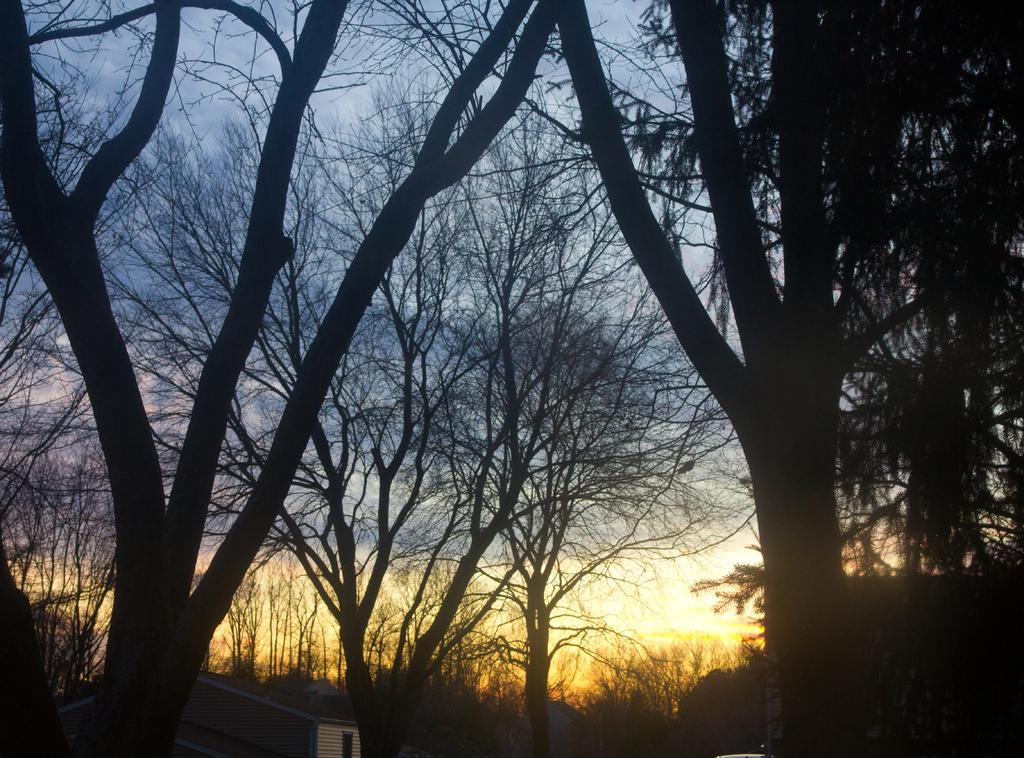What type of structure is visible in the image? There is a house in the image. Can you describe any specific features of the house? There is a window visible in the image. What type of natural elements can be seen in the image? There are trees in the image. What is visible in the sky in the image? Clouds are visible in the sky in the image. How many sticks are arranged in a face-like pattern in the image? There are no sticks arranged in a face-like pattern in the image. 